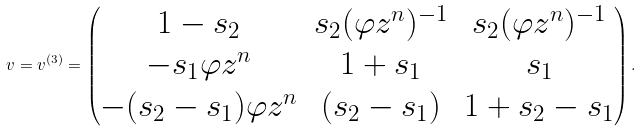<formula> <loc_0><loc_0><loc_500><loc_500>v = v ^ { ( 3 ) } = \begin{pmatrix} 1 - s _ { 2 } & s _ { 2 } ( \varphi z ^ { n } ) ^ { - 1 } & s _ { 2 } ( \varphi z ^ { n } ) ^ { - 1 } \\ - s _ { 1 } \varphi z ^ { n } & 1 + s _ { 1 } & s _ { 1 } \\ - ( s _ { 2 } - s _ { 1 } ) \varphi z ^ { n } & ( s _ { 2 } - s _ { 1 } ) & 1 + s _ { 2 } - s _ { 1 } \end{pmatrix} .</formula> 